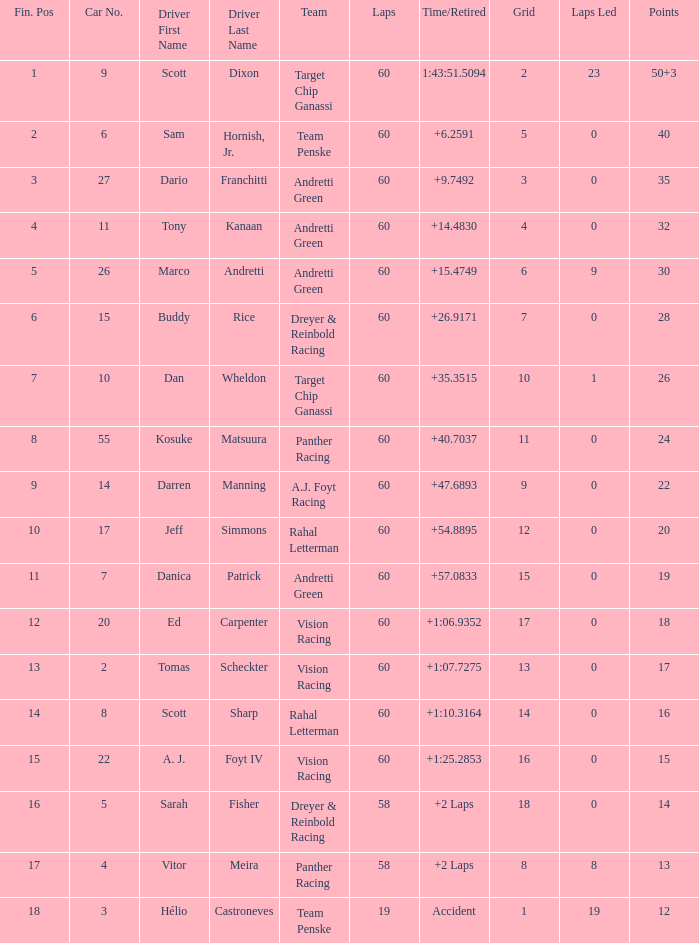Name the team of darren manning A.J. Foyt Racing. 